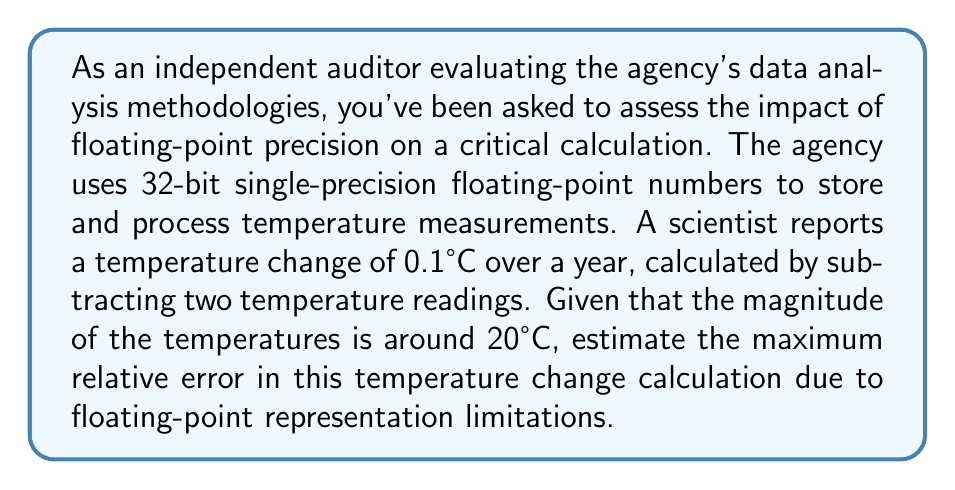Provide a solution to this math problem. To solve this problem, we need to understand the precision limitations of 32-bit single-precision floating-point numbers and how they affect calculations, especially when dealing with small differences between large numbers.

1. Precision of 32-bit float:
   32-bit floats have about 7 decimal digits of precision. The machine epsilon for 32-bit floats is approximately $2^{-23} \approx 1.19 \times 10^{-7}$.

2. Representation of temperatures:
   With temperatures around 20°C, we're dealing with numbers of magnitude $\sim 10^1$.

3. Relative error in representation:
   The relative error in representing a number $x$ is approximately:
   
   $$ \frac{\text{machine epsilon} \times |x|}{\text{|x|}} = \text{machine epsilon} \approx 1.19 \times 10^{-7} $$

4. Error propagation in subtraction:
   When subtracting two nearly equal numbers, the relative error can be much larger than the individual relative errors. If we subtract two numbers $a$ and $b$ that are close in value, the relative error in the result $(a-b)$ can be approximated as:

   $$ \text{Relative Error}_{(a-b)} \approx \frac{|a|}{|a-b|} \times \text{Relative Error}_a $$

5. Applying to our scenario:
   - $|a| \approx 20$ (magnitude of temperature readings)
   - $|a-b| = 0.1$ (reported temperature change)
   - Relative Error$_a \approx 1.19 \times 10^{-7}$ (from step 3)

   $$ \text{Relative Error}_{(a-b)} \approx \frac{20}{0.1} \times 1.19 \times 10^{-7} \approx 2.38 \times 10^{-5} $$

6. Converting to percentage:
   $2.38 \times 10^{-5} \times 100\% \approx 0.00238\%$

Therefore, the maximum relative error in the temperature change calculation due to floating-point representation limitations is approximately 0.00238% or about 0.0024%.
Answer: The maximum relative error in the temperature change calculation due to floating-point representation limitations is approximately 0.0024%. 